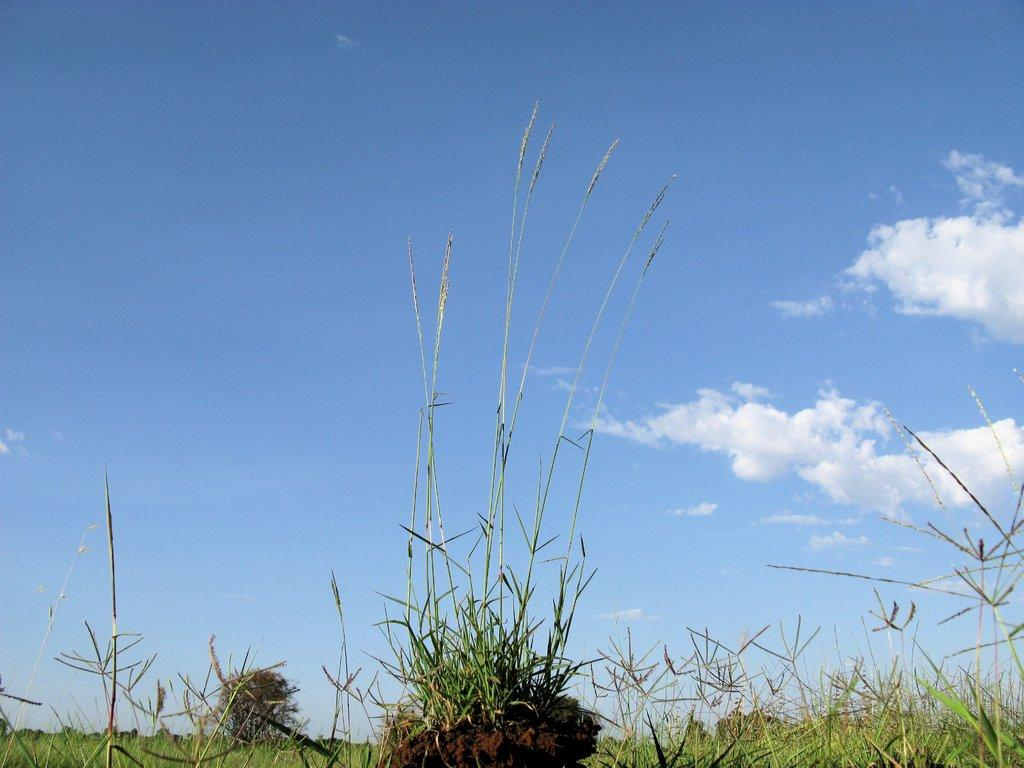What type of vegetation can be seen in the image? There is grass in the image. Are there any other plants visible besides the grass? Yes, there is a plant in the image. What part of the natural environment is visible in the image? The sky is visible in the image. What can be seen in the sky? There are clouds in the sky. Where is the sister standing in the image? There is no sister present in the image. What type of whip is being used to create the clouds in the image? There is no whip present in the image, and the clouds are natural formations in the sky. 